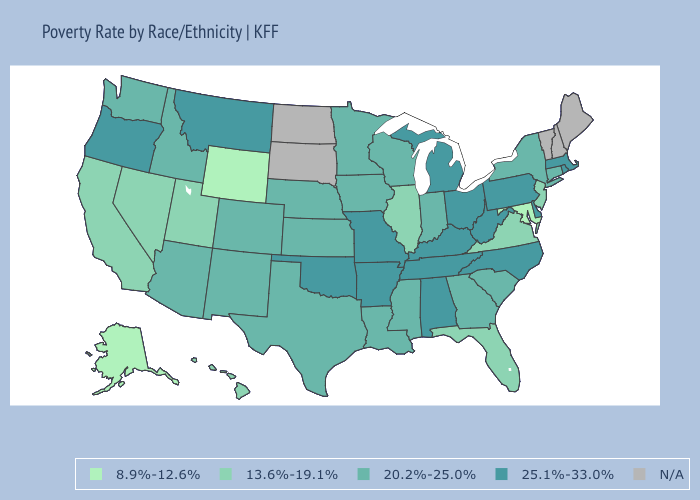Does the first symbol in the legend represent the smallest category?
Be succinct. Yes. Among the states that border Delaware , does Maryland have the highest value?
Answer briefly. No. Which states have the lowest value in the USA?
Quick response, please. Alaska, Maryland, Wyoming. What is the lowest value in the Northeast?
Write a very short answer. 13.6%-19.1%. What is the value of Wisconsin?
Answer briefly. 20.2%-25.0%. Is the legend a continuous bar?
Keep it brief. No. Name the states that have a value in the range 20.2%-25.0%?
Be succinct. Arizona, Colorado, Connecticut, Georgia, Idaho, Indiana, Iowa, Kansas, Louisiana, Minnesota, Mississippi, Nebraska, New Mexico, New York, South Carolina, Texas, Washington, Wisconsin. What is the value of Alabama?
Give a very brief answer. 25.1%-33.0%. Does the map have missing data?
Quick response, please. Yes. Among the states that border Michigan , which have the lowest value?
Short answer required. Indiana, Wisconsin. What is the value of Rhode Island?
Be succinct. 25.1%-33.0%. Does the first symbol in the legend represent the smallest category?
Give a very brief answer. Yes. 